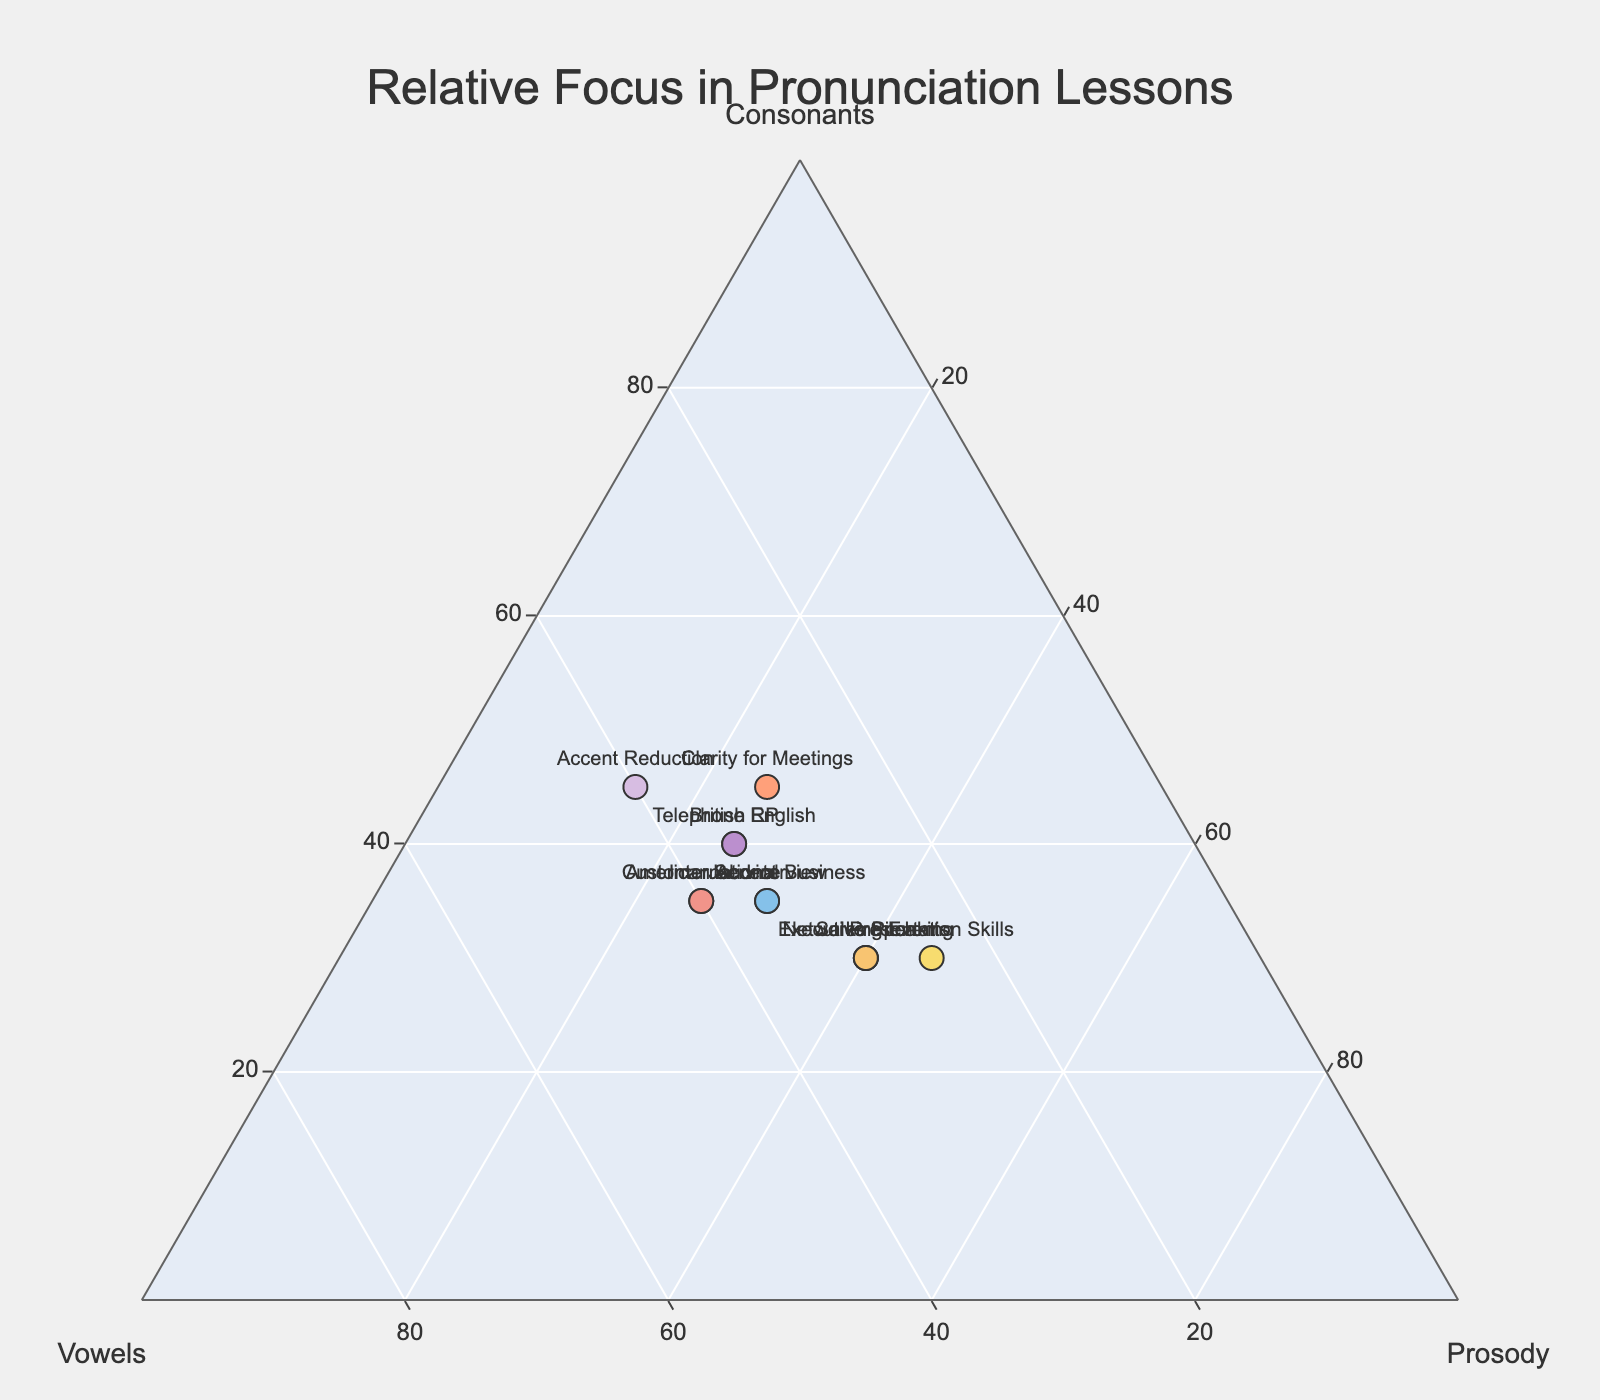What is the title of the plot? The title of the plot is usually prominently placed at the top of the diagram and is intended to give a quick summary of what the plot represents. In this figure, the title is located at the top center.
Answer: Relative Focus in Pronunciation Lessons Which approach places the greatest focus on prosody? By examining the plot, we see that "Presentation Skills," "Sales Pitch," "Executive Speaking," and "Networking Events" approaches are positioned closest to the prosody axis and have the highest prosody values.
Answer: Presentation Skills Which approach has the lowest focus on vowels? To find the approach with the lowest vowels, we look for the point with the smallest value along the 'Vowels' axis. "Presentation Skills" with 25% vowels is the lowest.
Answer: Presentation Skills What is the focus ratio of consonants to prosody in "Accent Reduction"? From the data, we see "Accent Reduction" has 45% focus on consonants and 15% on prosody. To find the ratio, divide 45 by 15.
Answer: 3:1 Which two approaches have the same focus distribution? Looking at the plot, we notice that "American Accent" and "Customer Service" have the same coordinates across all three dimensions.
Answer: American Accent and Customer Service What is the average focus on consonants across all approaches? Sum the consonant focus percentages for all approaches and divide by the number of approaches. The sum is 450 (40+35+30+45+35+30+40+35+30+35+45+30), and there are 12 approaches. So, average = 450/12.
Answer: 37.5 Which approach spends more time on vowels, "British RP" or "Executive Speaking"? Comparing their positions on the 'Vowels' axis, "British RP" has a value of 35%, and "Executive Speaking" has 30%.
Answer: British RP What is the combined focus on consonants and vowels for "Clarity for Meetings"? From the data, "Clarity for Meetings" has 45% consonants and 30% vowels. Adding these together gives us the combined focus.
Answer: 75% How many approaches have a higher focus on prosody than consonants? Counting the approaches where the prosody value exceeds the consonants value: "Executive Speaking," "Presentation Skills," "Sales Pitch," and "Networking Events."
Answer: Four approaches Which approach has the closest balance between consonants, vowels, and prosody? This is typically found by observing the points near the center of the ternary plot equidistant from all three axes. "International Business" with 35% consonants, 35% vowels, and 30% prosody.
Answer: International Business 